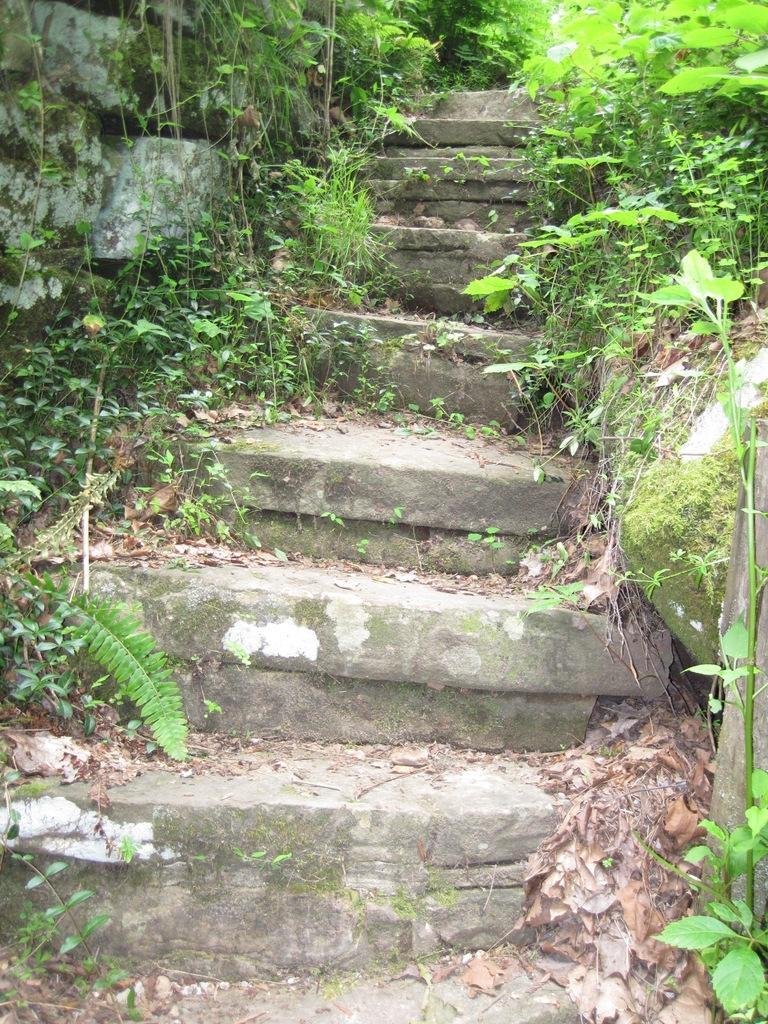Can you describe this image briefly? In the image in the center we can see staircase,wall,plants,dry leaves and grass. 